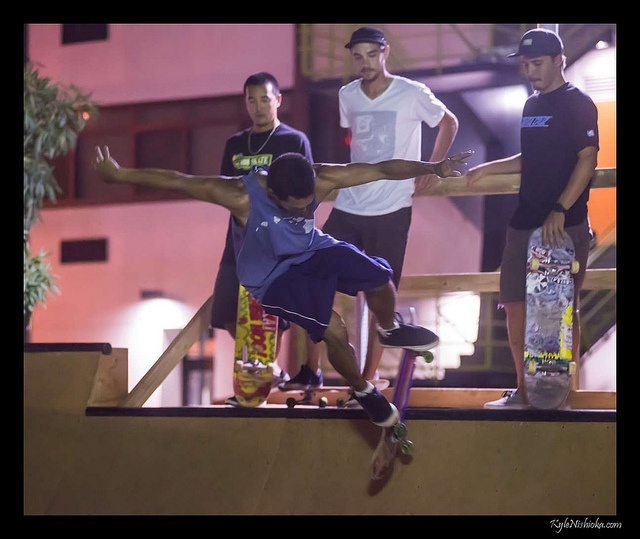Describe the objects in this image and their specific colors. I can see people in black, navy, and gray tones, people in black, gray, and purple tones, people in black, darkgray, and purple tones, skateboard in black, gray, and darkgray tones, and people in black, gray, and purple tones in this image. 